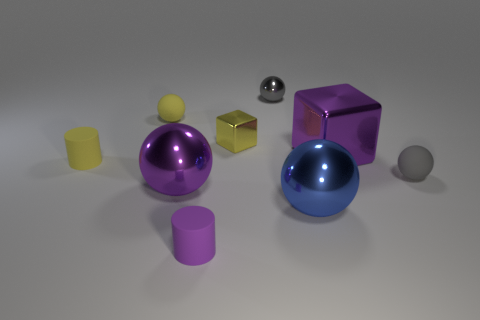Subtract all blue cubes. How many gray balls are left? 2 Subtract all big purple shiny spheres. How many spheres are left? 4 Subtract all yellow spheres. How many spheres are left? 4 Subtract 1 spheres. How many spheres are left? 4 Subtract all cyan balls. Subtract all blue blocks. How many balls are left? 5 Subtract all cubes. How many objects are left? 7 Subtract 0 brown cylinders. How many objects are left? 9 Subtract all small brown shiny balls. Subtract all matte cylinders. How many objects are left? 7 Add 6 blue spheres. How many blue spheres are left? 7 Add 8 small metal objects. How many small metal objects exist? 10 